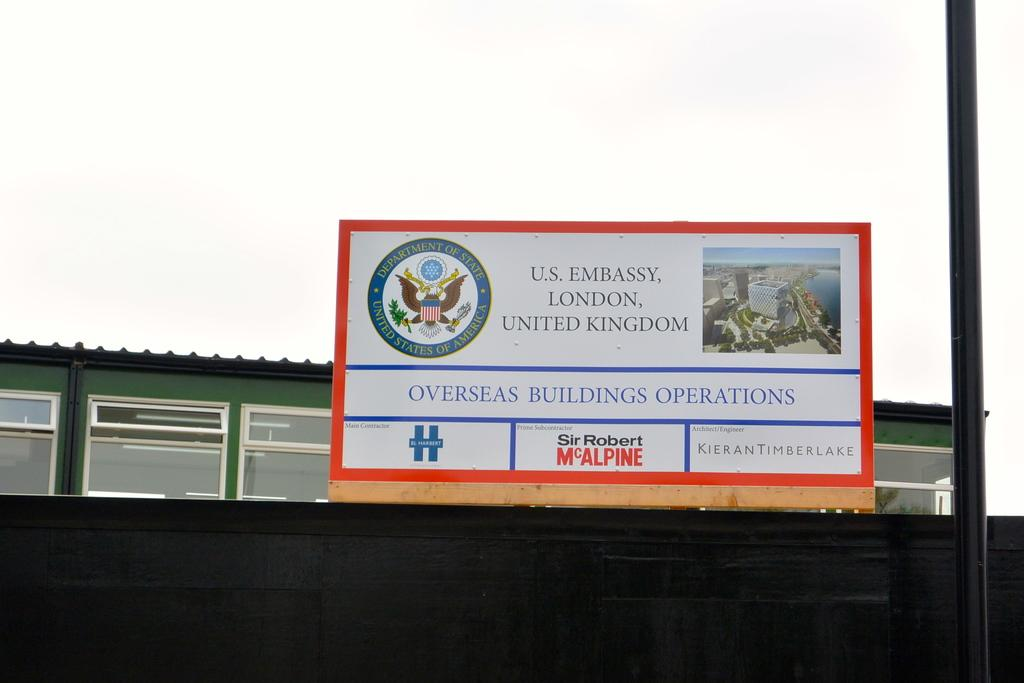What is on the board that is visible in the image? There is text on the board in the image. What can be seen on the right side of the image? There is a pole on the right side of the image. What is visible in the background of the image? There is a building in the background of the image. What is visible at the top of the image? The sky is visible at the top of the image. How many hooks are present in the image? There are no hooks present in the image. 